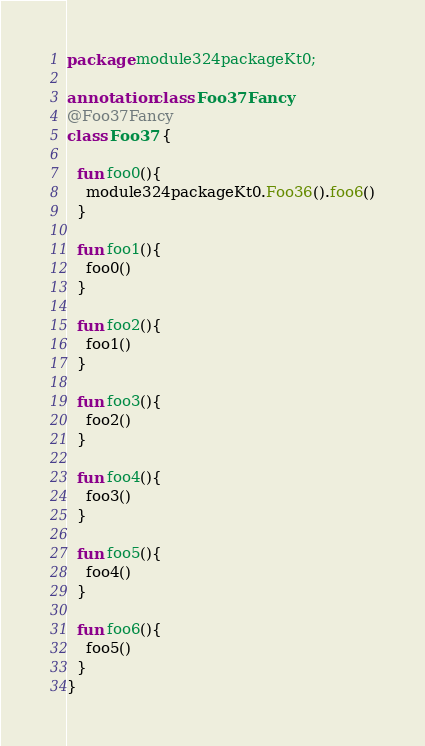<code> <loc_0><loc_0><loc_500><loc_500><_Kotlin_>package module324packageKt0;

annotation class Foo37Fancy
@Foo37Fancy
class Foo37 {

  fun foo0(){
    module324packageKt0.Foo36().foo6()
  }

  fun foo1(){
    foo0()
  }

  fun foo2(){
    foo1()
  }

  fun foo3(){
    foo2()
  }

  fun foo4(){
    foo3()
  }

  fun foo5(){
    foo4()
  }

  fun foo6(){
    foo5()
  }
}</code> 